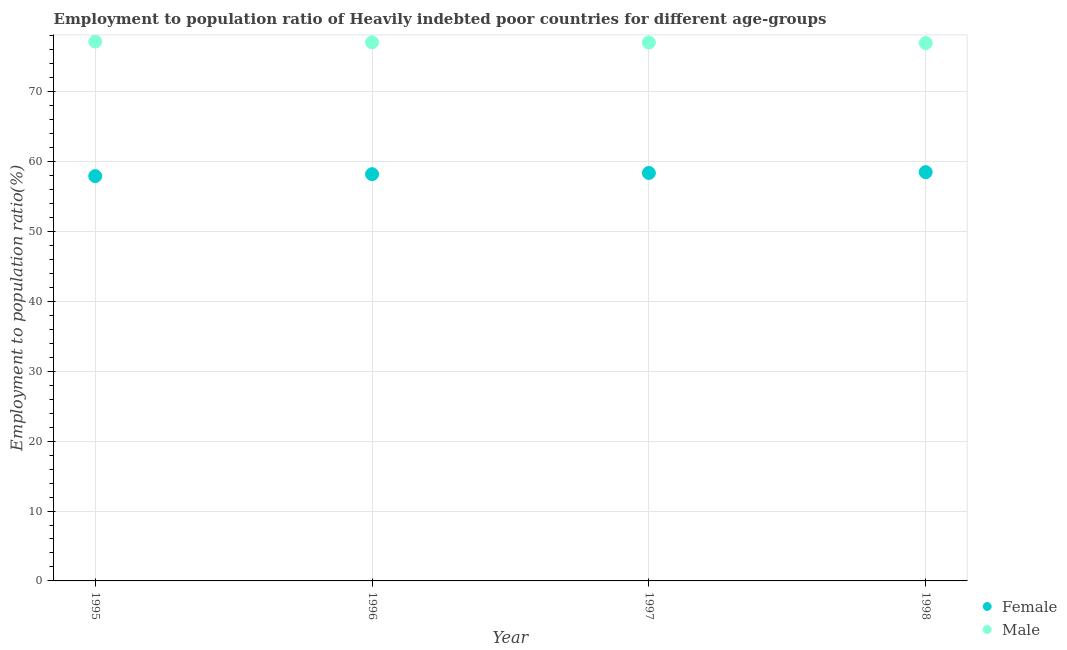How many different coloured dotlines are there?
Ensure brevity in your answer.  2. Is the number of dotlines equal to the number of legend labels?
Provide a succinct answer. Yes. What is the employment to population ratio(female) in 1995?
Your answer should be very brief. 57.94. Across all years, what is the maximum employment to population ratio(female)?
Offer a terse response. 58.5. Across all years, what is the minimum employment to population ratio(male)?
Your answer should be very brief. 76.97. What is the total employment to population ratio(male) in the graph?
Make the answer very short. 308.31. What is the difference between the employment to population ratio(female) in 1996 and that in 1998?
Offer a very short reply. -0.3. What is the difference between the employment to population ratio(male) in 1998 and the employment to population ratio(female) in 1995?
Provide a short and direct response. 19.04. What is the average employment to population ratio(female) per year?
Your answer should be compact. 58.26. In the year 1996, what is the difference between the employment to population ratio(male) and employment to population ratio(female)?
Keep it short and to the point. 18.87. What is the ratio of the employment to population ratio(female) in 1996 to that in 1997?
Your response must be concise. 1. Is the employment to population ratio(male) in 1995 less than that in 1996?
Offer a very short reply. No. What is the difference between the highest and the second highest employment to population ratio(male)?
Your answer should be compact. 0.1. What is the difference between the highest and the lowest employment to population ratio(female)?
Your response must be concise. 0.57. In how many years, is the employment to population ratio(female) greater than the average employment to population ratio(female) taken over all years?
Provide a succinct answer. 2. Is the sum of the employment to population ratio(male) in 1996 and 1998 greater than the maximum employment to population ratio(female) across all years?
Keep it short and to the point. Yes. Is the employment to population ratio(male) strictly greater than the employment to population ratio(female) over the years?
Keep it short and to the point. Yes. How many years are there in the graph?
Make the answer very short. 4. What is the difference between two consecutive major ticks on the Y-axis?
Give a very brief answer. 10. Are the values on the major ticks of Y-axis written in scientific E-notation?
Give a very brief answer. No. Does the graph contain grids?
Keep it short and to the point. Yes. Where does the legend appear in the graph?
Offer a very short reply. Bottom right. How many legend labels are there?
Ensure brevity in your answer.  2. How are the legend labels stacked?
Your response must be concise. Vertical. What is the title of the graph?
Your answer should be very brief. Employment to population ratio of Heavily indebted poor countries for different age-groups. What is the Employment to population ratio(%) of Female in 1995?
Give a very brief answer. 57.94. What is the Employment to population ratio(%) of Male in 1995?
Offer a terse response. 77.19. What is the Employment to population ratio(%) in Female in 1996?
Your answer should be compact. 58.21. What is the Employment to population ratio(%) of Male in 1996?
Ensure brevity in your answer.  77.08. What is the Employment to population ratio(%) in Female in 1997?
Your answer should be compact. 58.38. What is the Employment to population ratio(%) in Male in 1997?
Offer a terse response. 77.06. What is the Employment to population ratio(%) in Female in 1998?
Offer a terse response. 58.5. What is the Employment to population ratio(%) in Male in 1998?
Ensure brevity in your answer.  76.97. Across all years, what is the maximum Employment to population ratio(%) of Female?
Provide a succinct answer. 58.5. Across all years, what is the maximum Employment to population ratio(%) of Male?
Provide a short and direct response. 77.19. Across all years, what is the minimum Employment to population ratio(%) of Female?
Ensure brevity in your answer.  57.94. Across all years, what is the minimum Employment to population ratio(%) in Male?
Ensure brevity in your answer.  76.97. What is the total Employment to population ratio(%) of Female in the graph?
Offer a very short reply. 233.03. What is the total Employment to population ratio(%) in Male in the graph?
Your response must be concise. 308.31. What is the difference between the Employment to population ratio(%) in Female in 1995 and that in 1996?
Provide a short and direct response. -0.27. What is the difference between the Employment to population ratio(%) in Male in 1995 and that in 1996?
Offer a very short reply. 0.1. What is the difference between the Employment to population ratio(%) in Female in 1995 and that in 1997?
Provide a short and direct response. -0.45. What is the difference between the Employment to population ratio(%) in Male in 1995 and that in 1997?
Ensure brevity in your answer.  0.12. What is the difference between the Employment to population ratio(%) of Female in 1995 and that in 1998?
Ensure brevity in your answer.  -0.57. What is the difference between the Employment to population ratio(%) of Male in 1995 and that in 1998?
Your answer should be very brief. 0.21. What is the difference between the Employment to population ratio(%) in Female in 1996 and that in 1997?
Ensure brevity in your answer.  -0.18. What is the difference between the Employment to population ratio(%) of Male in 1996 and that in 1997?
Give a very brief answer. 0.02. What is the difference between the Employment to population ratio(%) in Female in 1996 and that in 1998?
Provide a short and direct response. -0.3. What is the difference between the Employment to population ratio(%) in Male in 1996 and that in 1998?
Your answer should be compact. 0.11. What is the difference between the Employment to population ratio(%) of Female in 1997 and that in 1998?
Offer a terse response. -0.12. What is the difference between the Employment to population ratio(%) in Male in 1997 and that in 1998?
Make the answer very short. 0.09. What is the difference between the Employment to population ratio(%) in Female in 1995 and the Employment to population ratio(%) in Male in 1996?
Provide a succinct answer. -19.15. What is the difference between the Employment to population ratio(%) of Female in 1995 and the Employment to population ratio(%) of Male in 1997?
Your response must be concise. -19.13. What is the difference between the Employment to population ratio(%) of Female in 1995 and the Employment to population ratio(%) of Male in 1998?
Offer a very short reply. -19.04. What is the difference between the Employment to population ratio(%) of Female in 1996 and the Employment to population ratio(%) of Male in 1997?
Give a very brief answer. -18.86. What is the difference between the Employment to population ratio(%) of Female in 1996 and the Employment to population ratio(%) of Male in 1998?
Ensure brevity in your answer.  -18.77. What is the difference between the Employment to population ratio(%) of Female in 1997 and the Employment to population ratio(%) of Male in 1998?
Offer a terse response. -18.59. What is the average Employment to population ratio(%) in Female per year?
Make the answer very short. 58.26. What is the average Employment to population ratio(%) of Male per year?
Offer a very short reply. 77.08. In the year 1995, what is the difference between the Employment to population ratio(%) in Female and Employment to population ratio(%) in Male?
Ensure brevity in your answer.  -19.25. In the year 1996, what is the difference between the Employment to population ratio(%) of Female and Employment to population ratio(%) of Male?
Your response must be concise. -18.87. In the year 1997, what is the difference between the Employment to population ratio(%) of Female and Employment to population ratio(%) of Male?
Offer a terse response. -18.68. In the year 1998, what is the difference between the Employment to population ratio(%) in Female and Employment to population ratio(%) in Male?
Provide a succinct answer. -18.47. What is the ratio of the Employment to population ratio(%) in Female in 1995 to that in 1996?
Your response must be concise. 1. What is the ratio of the Employment to population ratio(%) in Male in 1995 to that in 1996?
Your answer should be very brief. 1. What is the ratio of the Employment to population ratio(%) in Female in 1995 to that in 1997?
Provide a succinct answer. 0.99. What is the ratio of the Employment to population ratio(%) in Male in 1995 to that in 1997?
Offer a terse response. 1. What is the ratio of the Employment to population ratio(%) of Female in 1995 to that in 1998?
Provide a short and direct response. 0.99. What is the ratio of the Employment to population ratio(%) in Male in 1995 to that in 1998?
Your response must be concise. 1. What is the ratio of the Employment to population ratio(%) of Male in 1996 to that in 1997?
Your response must be concise. 1. What is the ratio of the Employment to population ratio(%) in Male in 1996 to that in 1998?
Your response must be concise. 1. What is the difference between the highest and the second highest Employment to population ratio(%) of Female?
Your answer should be very brief. 0.12. What is the difference between the highest and the second highest Employment to population ratio(%) of Male?
Your response must be concise. 0.1. What is the difference between the highest and the lowest Employment to population ratio(%) in Female?
Your answer should be very brief. 0.57. What is the difference between the highest and the lowest Employment to population ratio(%) in Male?
Your answer should be compact. 0.21. 